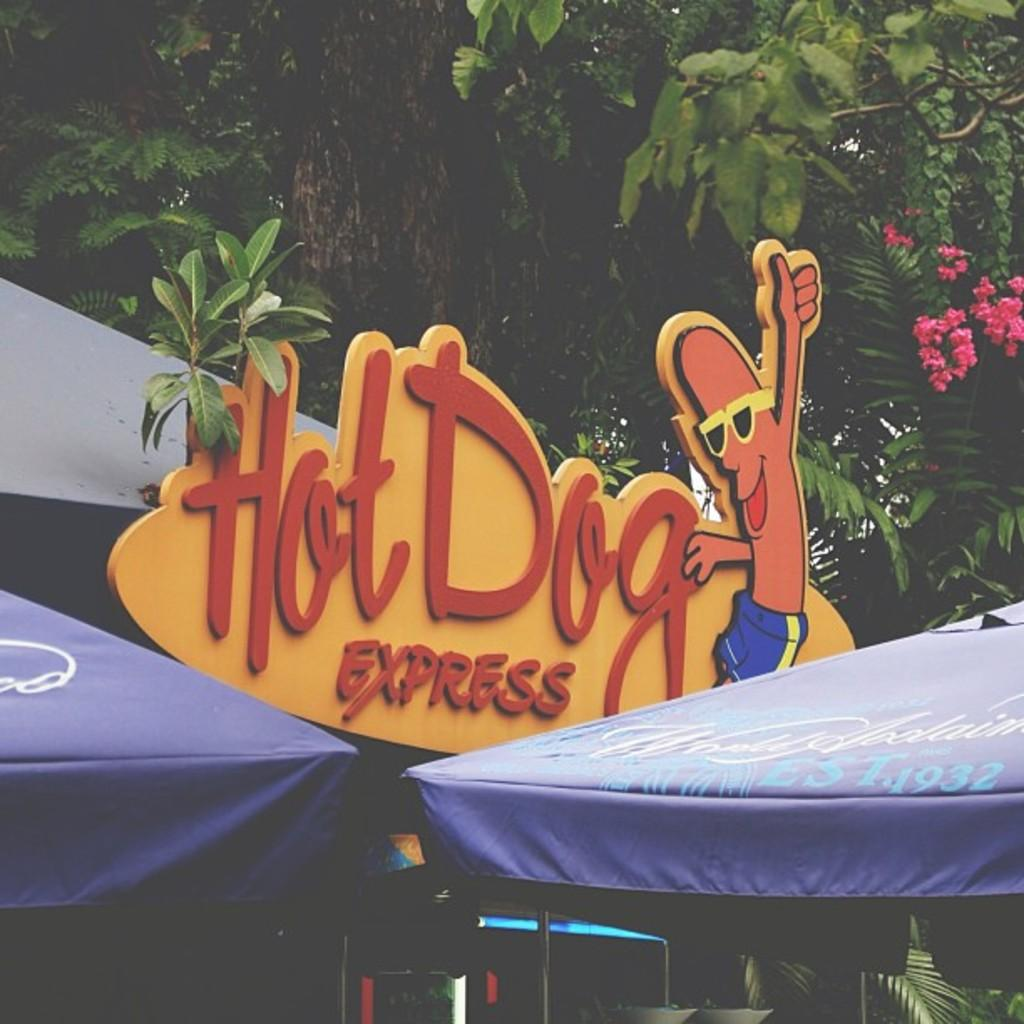What is written on the yellow sign board in the image? "HOT DOG EXPRESS" is written on the yellow sign board in the image. How many tents can be seen in the image? There are two tents in the image. What color are the trees in the background of the image? The trees in the background of the image are green. Where is the baby hiding the jewel in the image? There is no baby or jewel present in the image. 